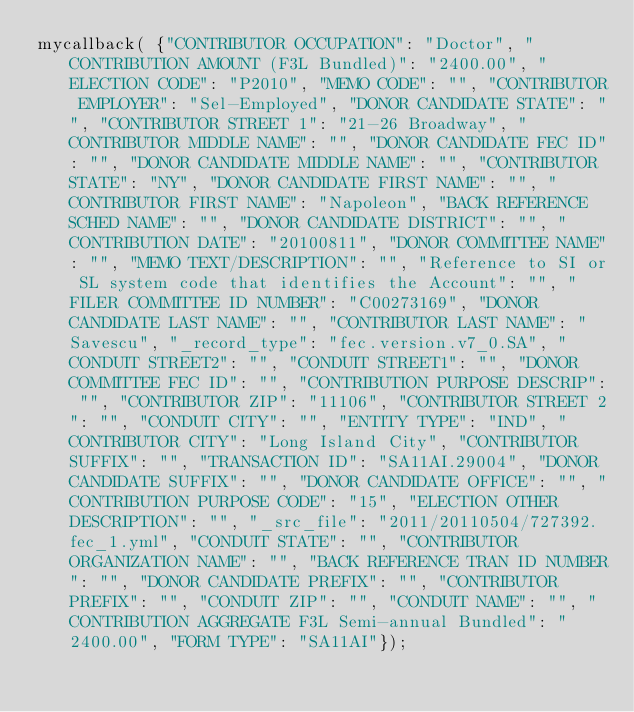<code> <loc_0><loc_0><loc_500><loc_500><_JavaScript_>mycallback( {"CONTRIBUTOR OCCUPATION": "Doctor", "CONTRIBUTION AMOUNT (F3L Bundled)": "2400.00", "ELECTION CODE": "P2010", "MEMO CODE": "", "CONTRIBUTOR EMPLOYER": "Sel-Employed", "DONOR CANDIDATE STATE": "", "CONTRIBUTOR STREET 1": "21-26 Broadway", "CONTRIBUTOR MIDDLE NAME": "", "DONOR CANDIDATE FEC ID": "", "DONOR CANDIDATE MIDDLE NAME": "", "CONTRIBUTOR STATE": "NY", "DONOR CANDIDATE FIRST NAME": "", "CONTRIBUTOR FIRST NAME": "Napoleon", "BACK REFERENCE SCHED NAME": "", "DONOR CANDIDATE DISTRICT": "", "CONTRIBUTION DATE": "20100811", "DONOR COMMITTEE NAME": "", "MEMO TEXT/DESCRIPTION": "", "Reference to SI or SL system code that identifies the Account": "", "FILER COMMITTEE ID NUMBER": "C00273169", "DONOR CANDIDATE LAST NAME": "", "CONTRIBUTOR LAST NAME": "Savescu", "_record_type": "fec.version.v7_0.SA", "CONDUIT STREET2": "", "CONDUIT STREET1": "", "DONOR COMMITTEE FEC ID": "", "CONTRIBUTION PURPOSE DESCRIP": "", "CONTRIBUTOR ZIP": "11106", "CONTRIBUTOR STREET 2": "", "CONDUIT CITY": "", "ENTITY TYPE": "IND", "CONTRIBUTOR CITY": "Long Island City", "CONTRIBUTOR SUFFIX": "", "TRANSACTION ID": "SA11AI.29004", "DONOR CANDIDATE SUFFIX": "", "DONOR CANDIDATE OFFICE": "", "CONTRIBUTION PURPOSE CODE": "15", "ELECTION OTHER DESCRIPTION": "", "_src_file": "2011/20110504/727392.fec_1.yml", "CONDUIT STATE": "", "CONTRIBUTOR ORGANIZATION NAME": "", "BACK REFERENCE TRAN ID NUMBER": "", "DONOR CANDIDATE PREFIX": "", "CONTRIBUTOR PREFIX": "", "CONDUIT ZIP": "", "CONDUIT NAME": "", "CONTRIBUTION AGGREGATE F3L Semi-annual Bundled": "2400.00", "FORM TYPE": "SA11AI"});</code> 